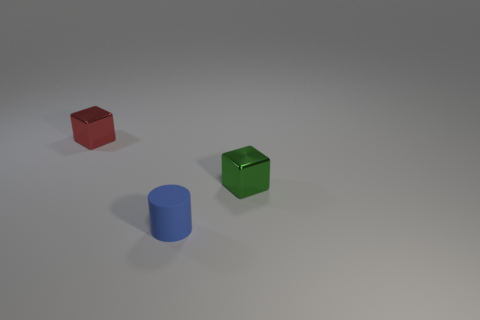Are there any green blocks that have the same size as the rubber cylinder?
Your response must be concise. Yes. There is a block that is on the right side of the tiny red object; what is it made of?
Offer a very short reply. Metal. Does the cube to the right of the small red metallic block have the same material as the small blue thing?
Provide a succinct answer. No. What shape is the green shiny thing that is the same size as the red metallic object?
Give a very brief answer. Cube. What number of blocks are the same color as the tiny cylinder?
Make the answer very short. 0. Is the number of cubes in front of the tiny red block less than the number of tiny blue cylinders in front of the blue matte cylinder?
Your response must be concise. No. Are there any small green cubes in front of the cylinder?
Provide a short and direct response. No. There is a matte thing in front of the red object on the left side of the blue matte cylinder; are there any tiny matte cylinders that are in front of it?
Give a very brief answer. No. There is a tiny shiny object in front of the small red object; is it the same shape as the tiny matte thing?
Offer a very short reply. No. The object that is the same material as the tiny red cube is what color?
Your answer should be very brief. Green. 